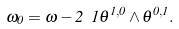<formula> <loc_0><loc_0><loc_500><loc_500>\omega _ { 0 } = \omega - 2 \ 1 \theta ^ { 1 , 0 } \wedge \theta ^ { 0 , 1 } .</formula> 